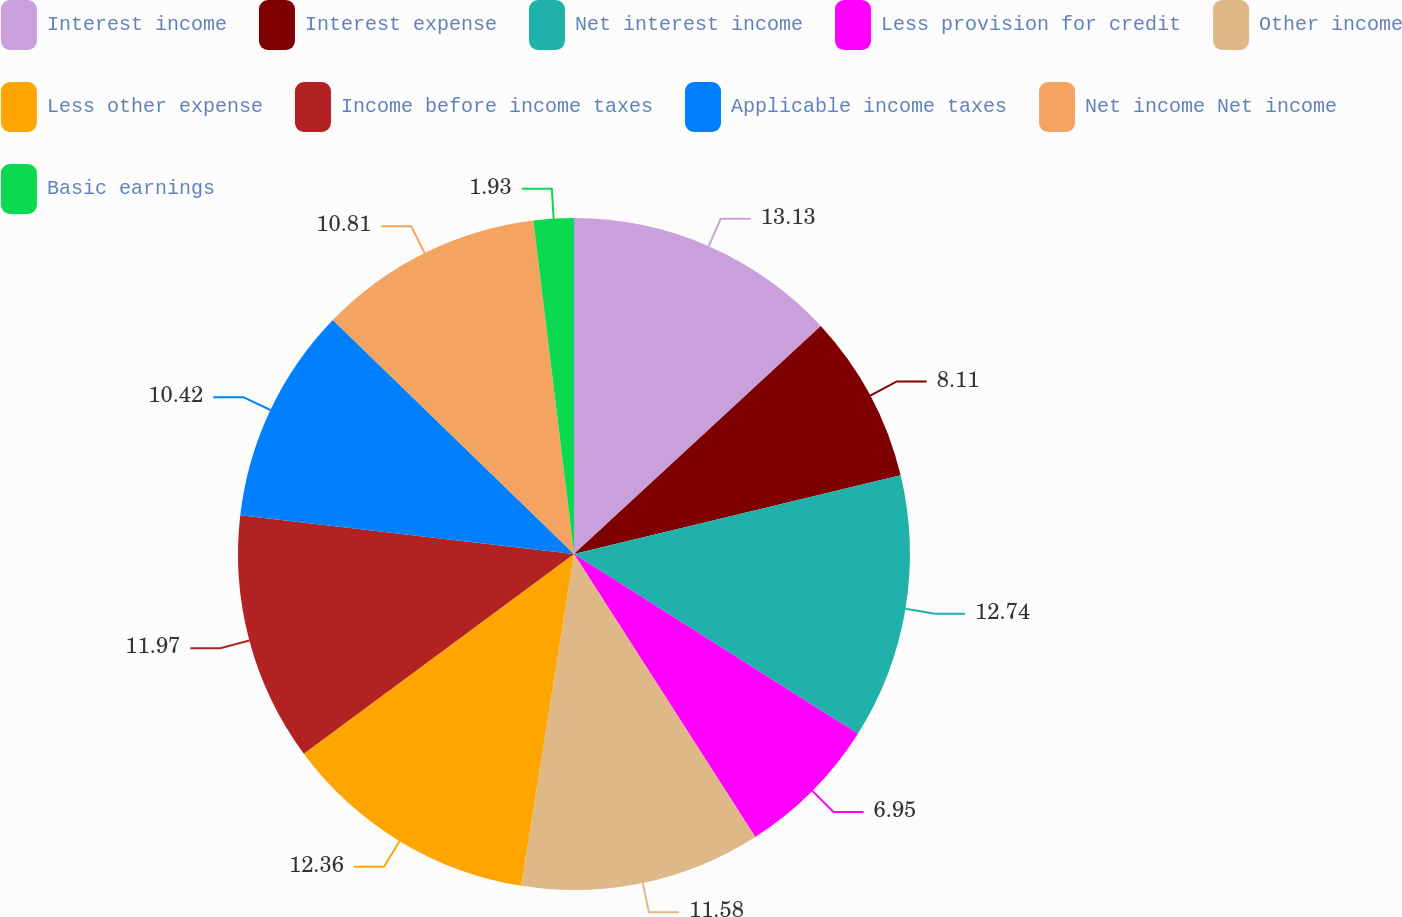<chart> <loc_0><loc_0><loc_500><loc_500><pie_chart><fcel>Interest income<fcel>Interest expense<fcel>Net interest income<fcel>Less provision for credit<fcel>Other income<fcel>Less other expense<fcel>Income before income taxes<fcel>Applicable income taxes<fcel>Net income Net income<fcel>Basic earnings<nl><fcel>13.13%<fcel>8.11%<fcel>12.74%<fcel>6.95%<fcel>11.58%<fcel>12.36%<fcel>11.97%<fcel>10.42%<fcel>10.81%<fcel>1.93%<nl></chart> 